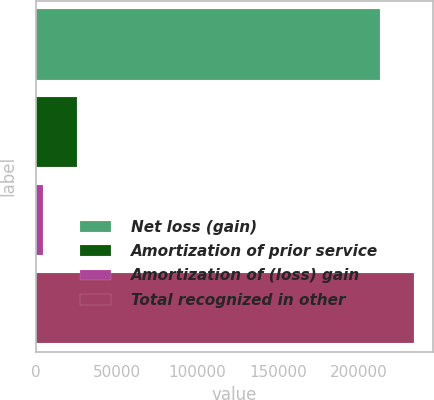Convert chart. <chart><loc_0><loc_0><loc_500><loc_500><bar_chart><fcel>Net loss (gain)<fcel>Amortization of prior service<fcel>Amortization of (loss) gain<fcel>Total recognized in other<nl><fcel>213239<fcel>25133.4<fcel>3942<fcel>234430<nl></chart> 